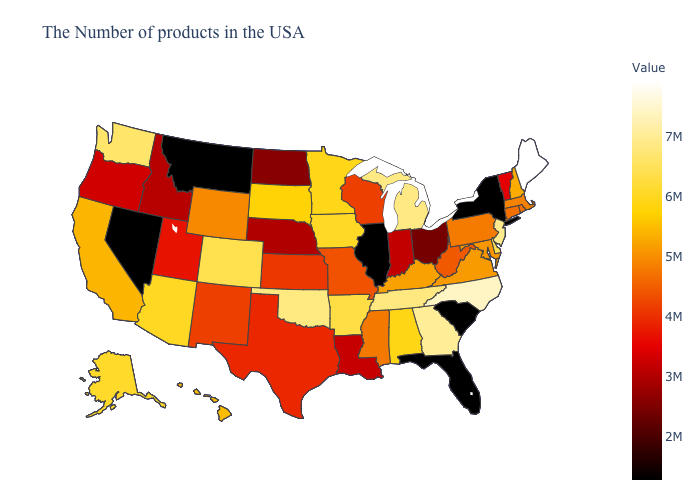Among the states that border New Hampshire , does Maine have the lowest value?
Give a very brief answer. No. 